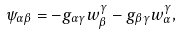<formula> <loc_0><loc_0><loc_500><loc_500>\psi _ { \alpha \beta } = - g _ { \alpha \gamma } w _ { \beta } ^ { \gamma } - g _ { \beta \gamma } w _ { \alpha } ^ { \gamma } ,</formula> 